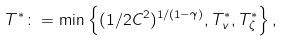<formula> <loc_0><loc_0><loc_500><loc_500>T ^ { * } \colon = \min \left \{ ( 1 / 2 C ^ { 2 } ) ^ { 1 / ( 1 - \gamma ) } , T _ { v } ^ { * } , T _ { \zeta } ^ { * } \right \} ,</formula> 